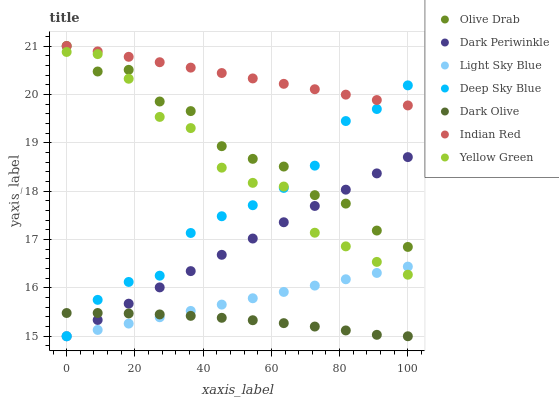Does Dark Olive have the minimum area under the curve?
Answer yes or no. Yes. Does Indian Red have the maximum area under the curve?
Answer yes or no. Yes. Does Light Sky Blue have the minimum area under the curve?
Answer yes or no. No. Does Light Sky Blue have the maximum area under the curve?
Answer yes or no. No. Is Dark Periwinkle the smoothest?
Answer yes or no. Yes. Is Yellow Green the roughest?
Answer yes or no. Yes. Is Dark Olive the smoothest?
Answer yes or no. No. Is Dark Olive the roughest?
Answer yes or no. No. Does Dark Olive have the lowest value?
Answer yes or no. Yes. Does Olive Drab have the lowest value?
Answer yes or no. No. Does Olive Drab have the highest value?
Answer yes or no. Yes. Does Light Sky Blue have the highest value?
Answer yes or no. No. Is Dark Olive less than Yellow Green?
Answer yes or no. Yes. Is Indian Red greater than Light Sky Blue?
Answer yes or no. Yes. Does Dark Olive intersect Dark Periwinkle?
Answer yes or no. Yes. Is Dark Olive less than Dark Periwinkle?
Answer yes or no. No. Is Dark Olive greater than Dark Periwinkle?
Answer yes or no. No. Does Dark Olive intersect Yellow Green?
Answer yes or no. No. 